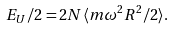<formula> <loc_0><loc_0><loc_500><loc_500>E _ { U } / 2 = 2 N \langle m \omega ^ { 2 } R ^ { 2 } / 2 \rangle .</formula> 